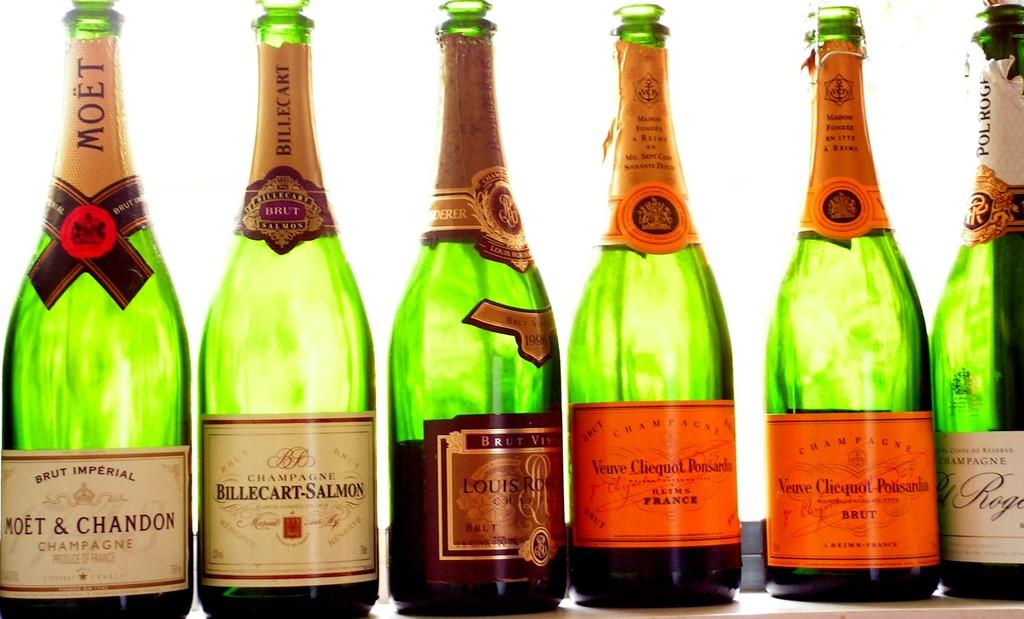What objects are present in the image? There are bottles in the image. What can be seen on the bottles? The bottles have stickers on them. How much dust is visible on the bottles in the image? There is no mention of dust in the image, so it cannot be determined how much dust is visible on the bottles. 